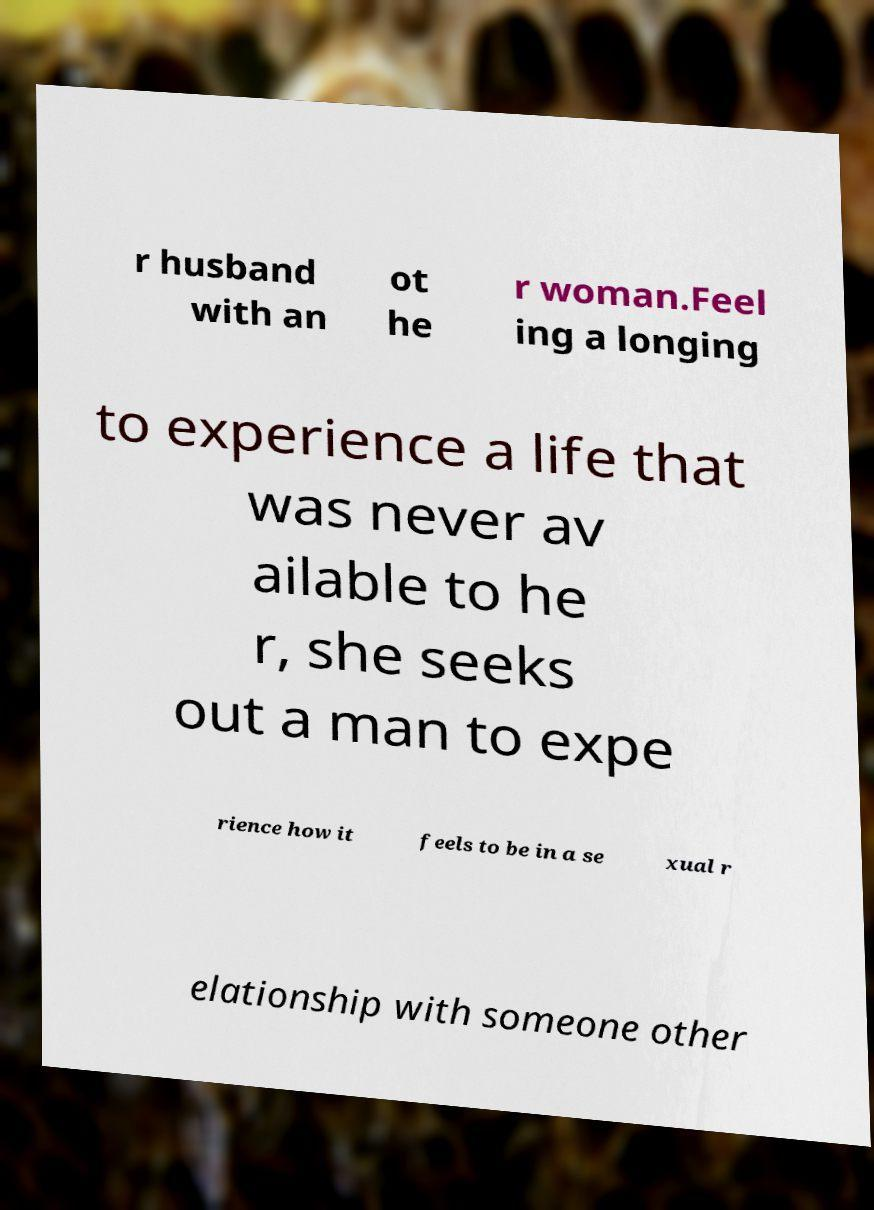Can you accurately transcribe the text from the provided image for me? r husband with an ot he r woman.Feel ing a longing to experience a life that was never av ailable to he r, she seeks out a man to expe rience how it feels to be in a se xual r elationship with someone other 